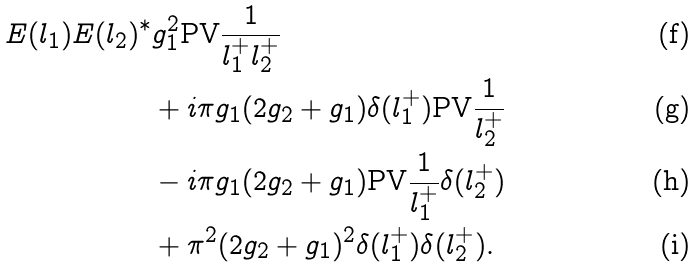Convert formula to latex. <formula><loc_0><loc_0><loc_500><loc_500>E ( l _ { 1 } ) E ( l _ { 2 } ) ^ { * } & g _ { 1 } ^ { 2 } \text {PV} \frac { 1 } { l _ { 1 } ^ { + } l _ { 2 } ^ { + } } \\ & + i \pi g _ { 1 } ( 2 g _ { 2 } + g _ { 1 } ) \delta ( l _ { 1 } ^ { + } ) \text {PV} \frac { 1 } { l _ { 2 } ^ { + } } \\ & - i \pi g _ { 1 } ( 2 g _ { 2 } + g _ { 1 } ) \text {PV} \frac { 1 } { l _ { 1 } ^ { + } } \delta ( l _ { 2 } ^ { + } ) \\ & + \pi ^ { 2 } ( 2 g _ { 2 } + g _ { 1 } ) ^ { 2 } \delta ( l _ { 1 } ^ { + } ) \delta ( l _ { 2 } ^ { + } ) .</formula> 